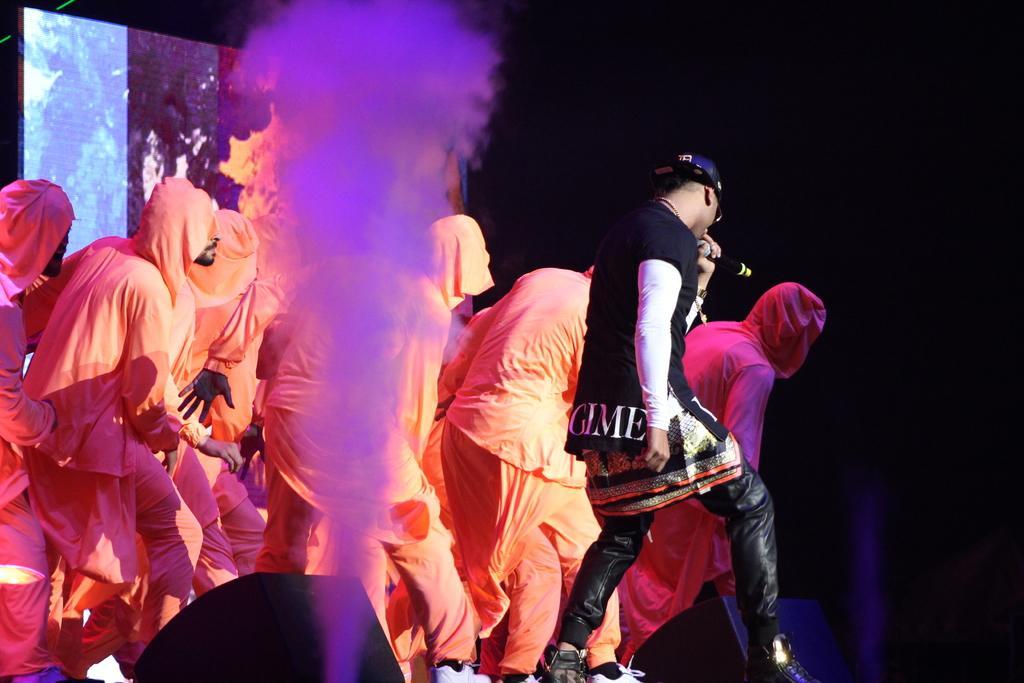In one or two sentences, can you explain what this image depicts? In this image we can see a person standing, singing a song by using a mic and also some people behind him. We can also see some smoke and speakers. 